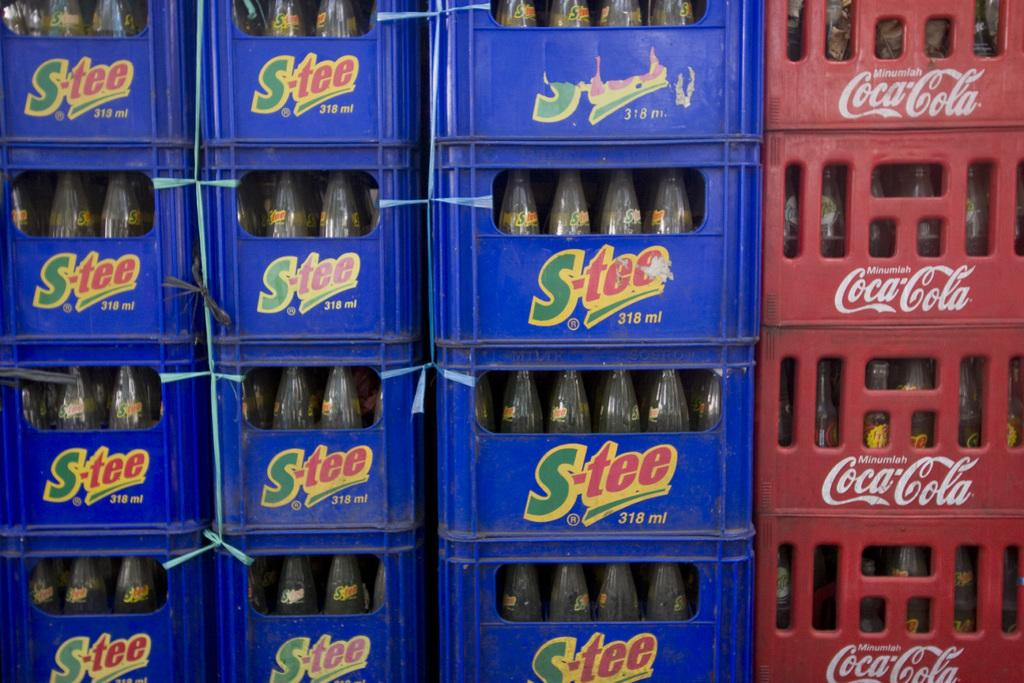What types of objects are present in the image? There are containers and bottles in the image. Can you describe the containers in the image? The containers in the image are not specified, but they are present. What can you tell me about the bottles in the image? The bottles in the image are also not specified, but they are present. How many loaves of bread are visible in the image? There is no bread present in the image. What is the wealth status of the woman in the image? There is no woman present in the image. 